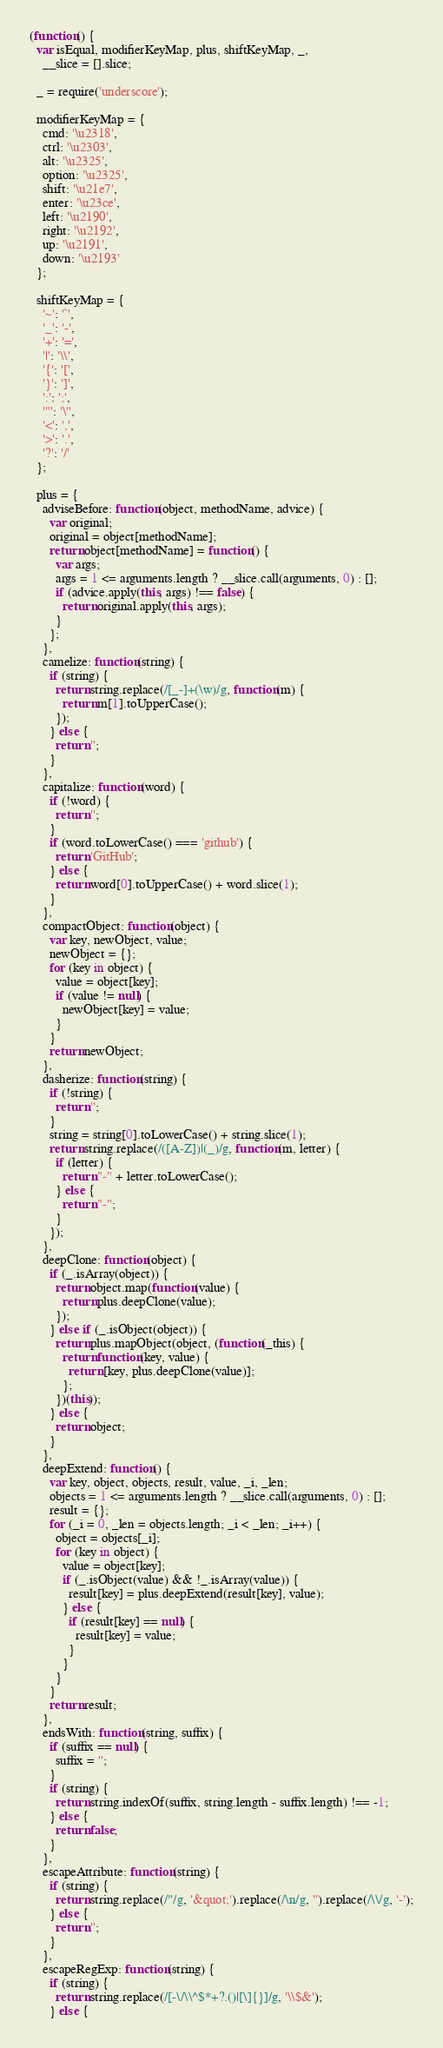<code> <loc_0><loc_0><loc_500><loc_500><_JavaScript_>(function() {
  var isEqual, modifierKeyMap, plus, shiftKeyMap, _,
    __slice = [].slice;

  _ = require('underscore');

  modifierKeyMap = {
    cmd: '\u2318',
    ctrl: '\u2303',
    alt: '\u2325',
    option: '\u2325',
    shift: '\u21e7',
    enter: '\u23ce',
    left: '\u2190',
    right: '\u2192',
    up: '\u2191',
    down: '\u2193'
  };

  shiftKeyMap = {
    '~': '`',
    '_': '-',
    '+': '=',
    '|': '\\',
    '{': '[',
    '}': ']',
    ':': ';',
    '"': '\'',
    '<': ',',
    '>': '.',
    '?': '/'
  };

  plus = {
    adviseBefore: function(object, methodName, advice) {
      var original;
      original = object[methodName];
      return object[methodName] = function() {
        var args;
        args = 1 <= arguments.length ? __slice.call(arguments, 0) : [];
        if (advice.apply(this, args) !== false) {
          return original.apply(this, args);
        }
      };
    },
    camelize: function(string) {
      if (string) {
        return string.replace(/[_-]+(\w)/g, function(m) {
          return m[1].toUpperCase();
        });
      } else {
        return '';
      }
    },
    capitalize: function(word) {
      if (!word) {
        return '';
      }
      if (word.toLowerCase() === 'github') {
        return 'GitHub';
      } else {
        return word[0].toUpperCase() + word.slice(1);
      }
    },
    compactObject: function(object) {
      var key, newObject, value;
      newObject = {};
      for (key in object) {
        value = object[key];
        if (value != null) {
          newObject[key] = value;
        }
      }
      return newObject;
    },
    dasherize: function(string) {
      if (!string) {
        return '';
      }
      string = string[0].toLowerCase() + string.slice(1);
      return string.replace(/([A-Z])|(_)/g, function(m, letter) {
        if (letter) {
          return "-" + letter.toLowerCase();
        } else {
          return "-";
        }
      });
    },
    deepClone: function(object) {
      if (_.isArray(object)) {
        return object.map(function(value) {
          return plus.deepClone(value);
        });
      } else if (_.isObject(object)) {
        return plus.mapObject(object, (function(_this) {
          return function(key, value) {
            return [key, plus.deepClone(value)];
          };
        })(this));
      } else {
        return object;
      }
    },
    deepExtend: function() {
      var key, object, objects, result, value, _i, _len;
      objects = 1 <= arguments.length ? __slice.call(arguments, 0) : [];
      result = {};
      for (_i = 0, _len = objects.length; _i < _len; _i++) {
        object = objects[_i];
        for (key in object) {
          value = object[key];
          if (_.isObject(value) && !_.isArray(value)) {
            result[key] = plus.deepExtend(result[key], value);
          } else {
            if (result[key] == null) {
              result[key] = value;
            }
          }
        }
      }
      return result;
    },
    endsWith: function(string, suffix) {
      if (suffix == null) {
        suffix = '';
      }
      if (string) {
        return string.indexOf(suffix, string.length - suffix.length) !== -1;
      } else {
        return false;
      }
    },
    escapeAttribute: function(string) {
      if (string) {
        return string.replace(/"/g, '&quot;').replace(/\n/g, '').replace(/\\/g, '-');
      } else {
        return '';
      }
    },
    escapeRegExp: function(string) {
      if (string) {
        return string.replace(/[-\/\\^$*+?.()|[\]{}]/g, '\\$&');
      } else {</code> 